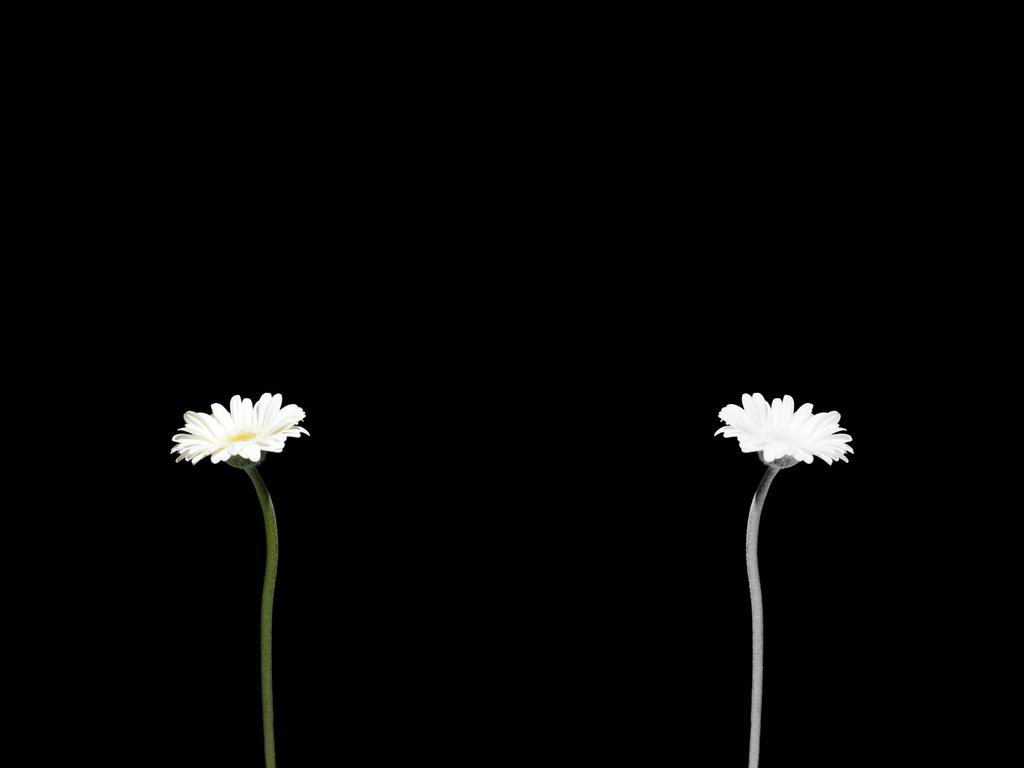How many flowers are present in the image? There are two flowers in the image. What part of the flowers is connected to the stem? The flowers have pedicles, which are the parts connecting them to the stem. What can be observed about the background of the image? The background of the image is dark. What type of fear do the flowers exhibit in the image? The flowers do not exhibit fear in the image, as they are inanimate objects and do not have emotions. 